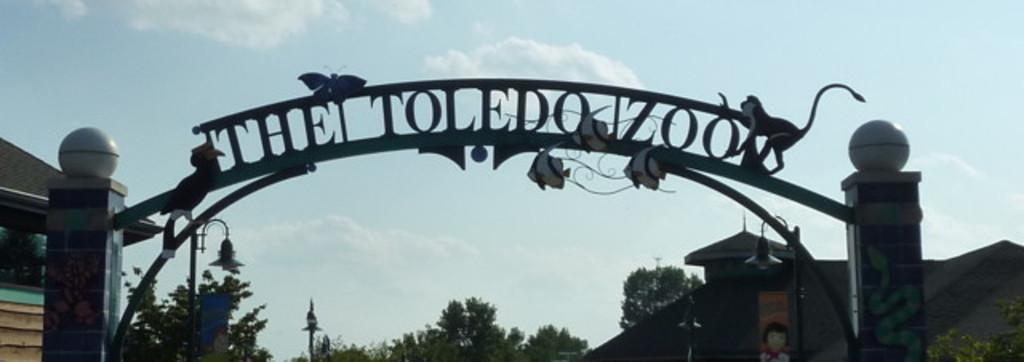How would you summarize this image in a sentence or two? In the foreground there is an arc of a zoo. In the background there are trees, buildings. Here there are lights. There are structures of animals on the arch. 